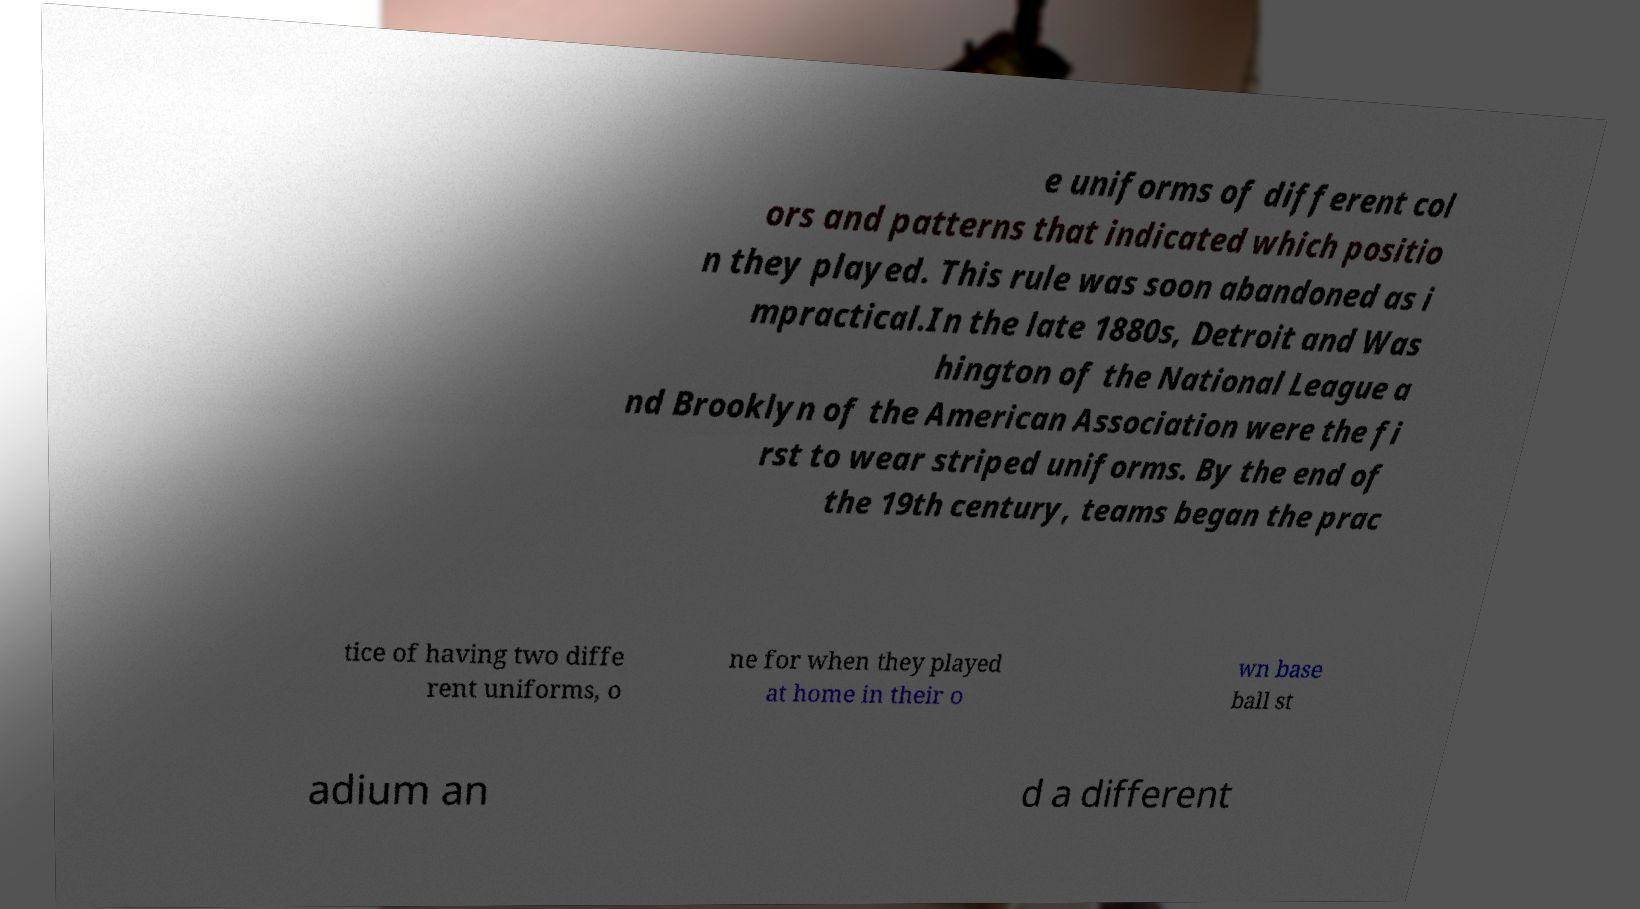I need the written content from this picture converted into text. Can you do that? e uniforms of different col ors and patterns that indicated which positio n they played. This rule was soon abandoned as i mpractical.In the late 1880s, Detroit and Was hington of the National League a nd Brooklyn of the American Association were the fi rst to wear striped uniforms. By the end of the 19th century, teams began the prac tice of having two diffe rent uniforms, o ne for when they played at home in their o wn base ball st adium an d a different 